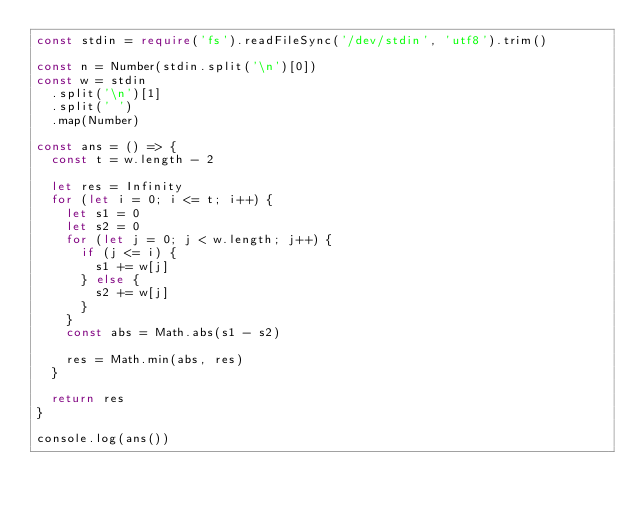<code> <loc_0><loc_0><loc_500><loc_500><_TypeScript_>const stdin = require('fs').readFileSync('/dev/stdin', 'utf8').trim()

const n = Number(stdin.split('\n')[0])
const w = stdin
  .split('\n')[1]
  .split(' ')
  .map(Number)

const ans = () => {
  const t = w.length - 2

  let res = Infinity
  for (let i = 0; i <= t; i++) {
    let s1 = 0
    let s2 = 0
    for (let j = 0; j < w.length; j++) {
      if (j <= i) {
        s1 += w[j]
      } else {
        s2 += w[j]
      }
    }
    const abs = Math.abs(s1 - s2)

    res = Math.min(abs, res)
  }

  return res
}

console.log(ans())
</code> 